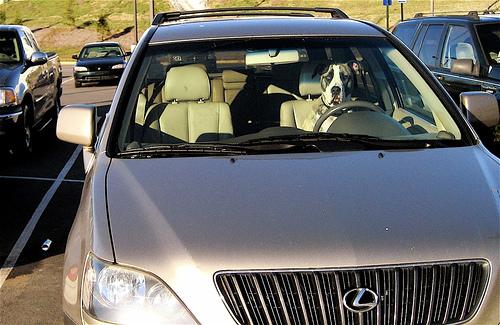What color is the car's interior?
Short answer required. Tan. Where is the dog sitting?
Short answer required. Drivers seat. What make is the car?
Concise answer only. Lexus. 